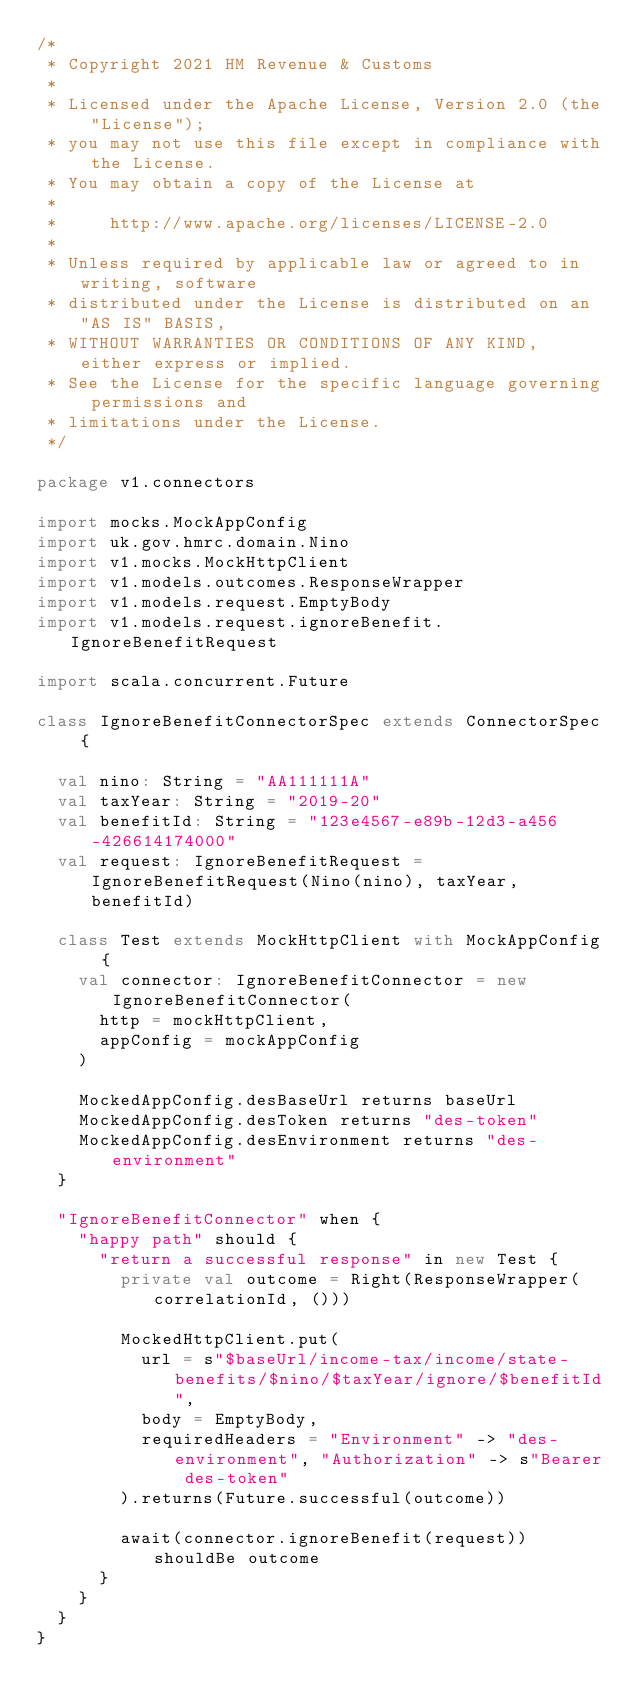<code> <loc_0><loc_0><loc_500><loc_500><_Scala_>/*
 * Copyright 2021 HM Revenue & Customs
 *
 * Licensed under the Apache License, Version 2.0 (the "License");
 * you may not use this file except in compliance with the License.
 * You may obtain a copy of the License at
 *
 *     http://www.apache.org/licenses/LICENSE-2.0
 *
 * Unless required by applicable law or agreed to in writing, software
 * distributed under the License is distributed on an "AS IS" BASIS,
 * WITHOUT WARRANTIES OR CONDITIONS OF ANY KIND, either express or implied.
 * See the License for the specific language governing permissions and
 * limitations under the License.
 */

package v1.connectors

import mocks.MockAppConfig
import uk.gov.hmrc.domain.Nino
import v1.mocks.MockHttpClient
import v1.models.outcomes.ResponseWrapper
import v1.models.request.EmptyBody
import v1.models.request.ignoreBenefit.IgnoreBenefitRequest

import scala.concurrent.Future

class IgnoreBenefitConnectorSpec extends ConnectorSpec {

  val nino: String = "AA111111A"
  val taxYear: String = "2019-20"
  val benefitId: String = "123e4567-e89b-12d3-a456-426614174000"
  val request: IgnoreBenefitRequest = IgnoreBenefitRequest(Nino(nino), taxYear, benefitId)

  class Test extends MockHttpClient with MockAppConfig {
    val connector: IgnoreBenefitConnector = new IgnoreBenefitConnector(
      http = mockHttpClient,
      appConfig = mockAppConfig
    )

    MockedAppConfig.desBaseUrl returns baseUrl
    MockedAppConfig.desToken returns "des-token"
    MockedAppConfig.desEnvironment returns "des-environment"
  }

  "IgnoreBenefitConnector" when {
    "happy path" should {
      "return a successful response" in new Test {
        private val outcome = Right(ResponseWrapper(correlationId, ()))

        MockedHttpClient.put(
          url = s"$baseUrl/income-tax/income/state-benefits/$nino/$taxYear/ignore/$benefitId",
          body = EmptyBody,
          requiredHeaders = "Environment" -> "des-environment", "Authorization" -> s"Bearer des-token"
        ).returns(Future.successful(outcome))

        await(connector.ignoreBenefit(request)) shouldBe outcome
      }
    }
  }
}
</code> 